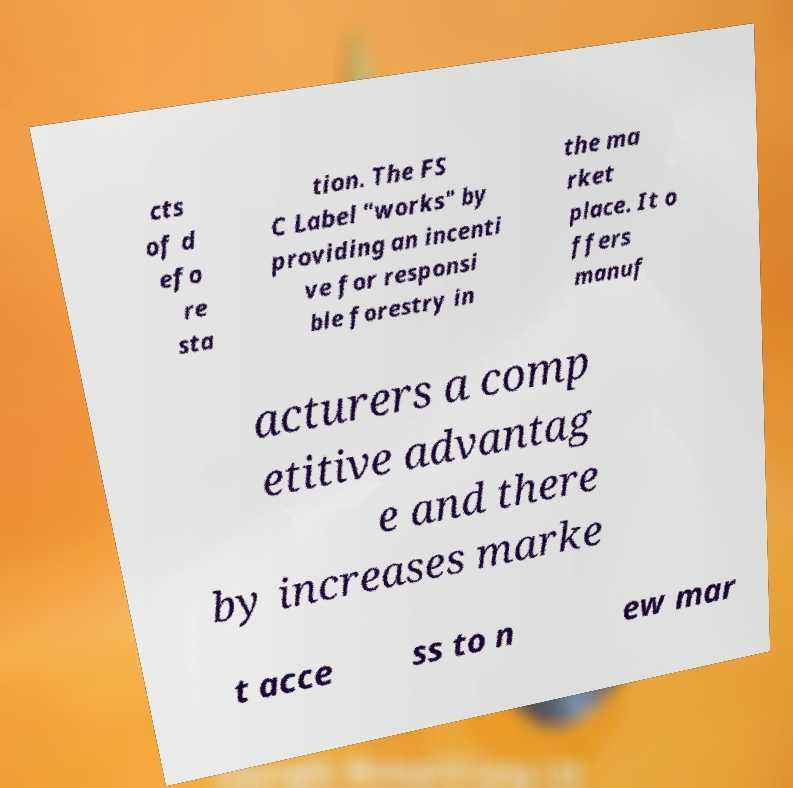Please identify and transcribe the text found in this image. cts of d efo re sta tion. The FS C Label "works" by providing an incenti ve for responsi ble forestry in the ma rket place. It o ffers manuf acturers a comp etitive advantag e and there by increases marke t acce ss to n ew mar 